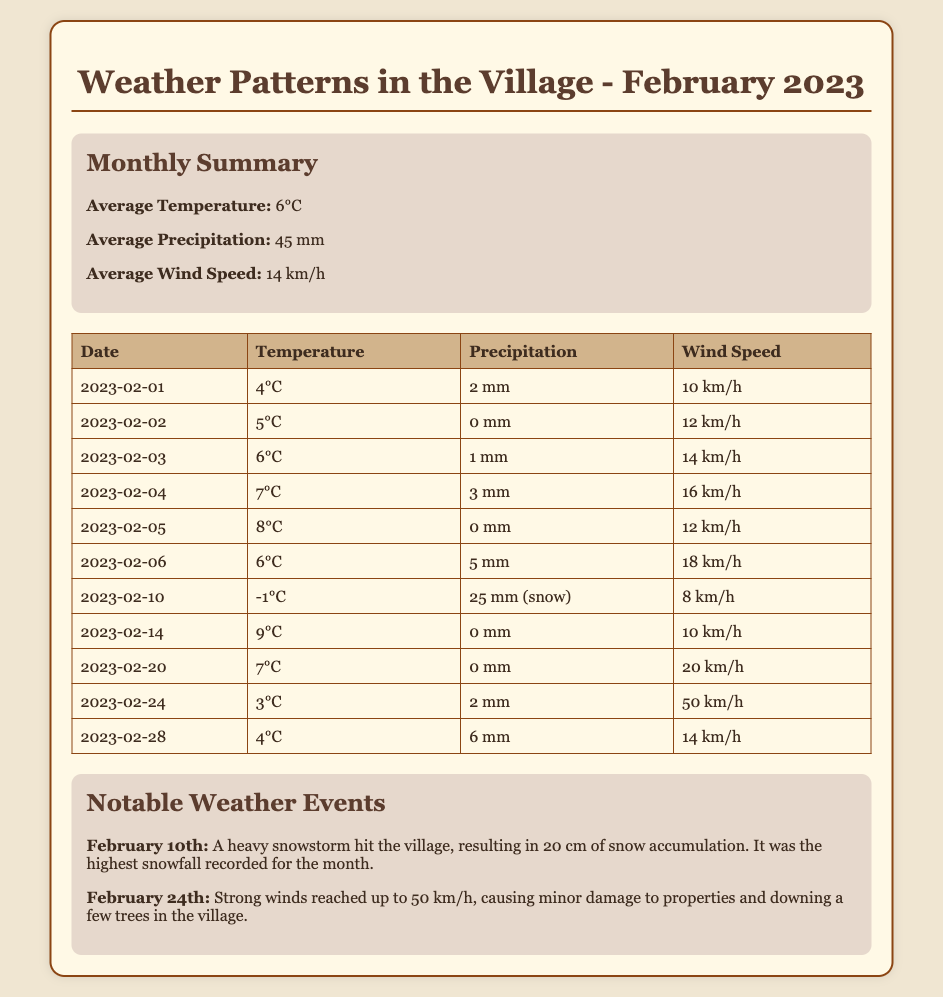What was the average temperature in February 2023? The average temperature is stated in the monthly summary section as 6°C.
Answer: 6°C What was the total precipitation recorded on February 10th? The daily data for February 10th shows a precipitation of 25 mm (snow).
Answer: 25 mm (snow) What was the highest wind speed recorded in February 2023? The highest wind speed recorded is 50 km/h on February 24th.
Answer: 50 km/h On which date did a heavy snowstorm occur? The notable weather events highlight that the snowstorm occurred on February 10th.
Answer: February 10th What was the average wind speed for February 2023? The average wind speed is mentioned in the summary section as 14 km/h.
Answer: 14 km/h How much precipitation was recorded on February 14th? The daily data shows that there was no precipitation recorded on February 14th.
Answer: 0 mm Which day had the lowest temperature recorded? The table indicates that February 10th had the lowest temperature of -1°C.
Answer: -1°C What notable weather event happened on February 24th? The document states that strong winds reached up to 50 km/h, causing minor damage.
Answer: Strong winds How many days in February had precipitation greater than 4 mm? By reviewing the daily data, only February 6th and February 10th exceeded 4 mm of precipitation.
Answer: 2 days 